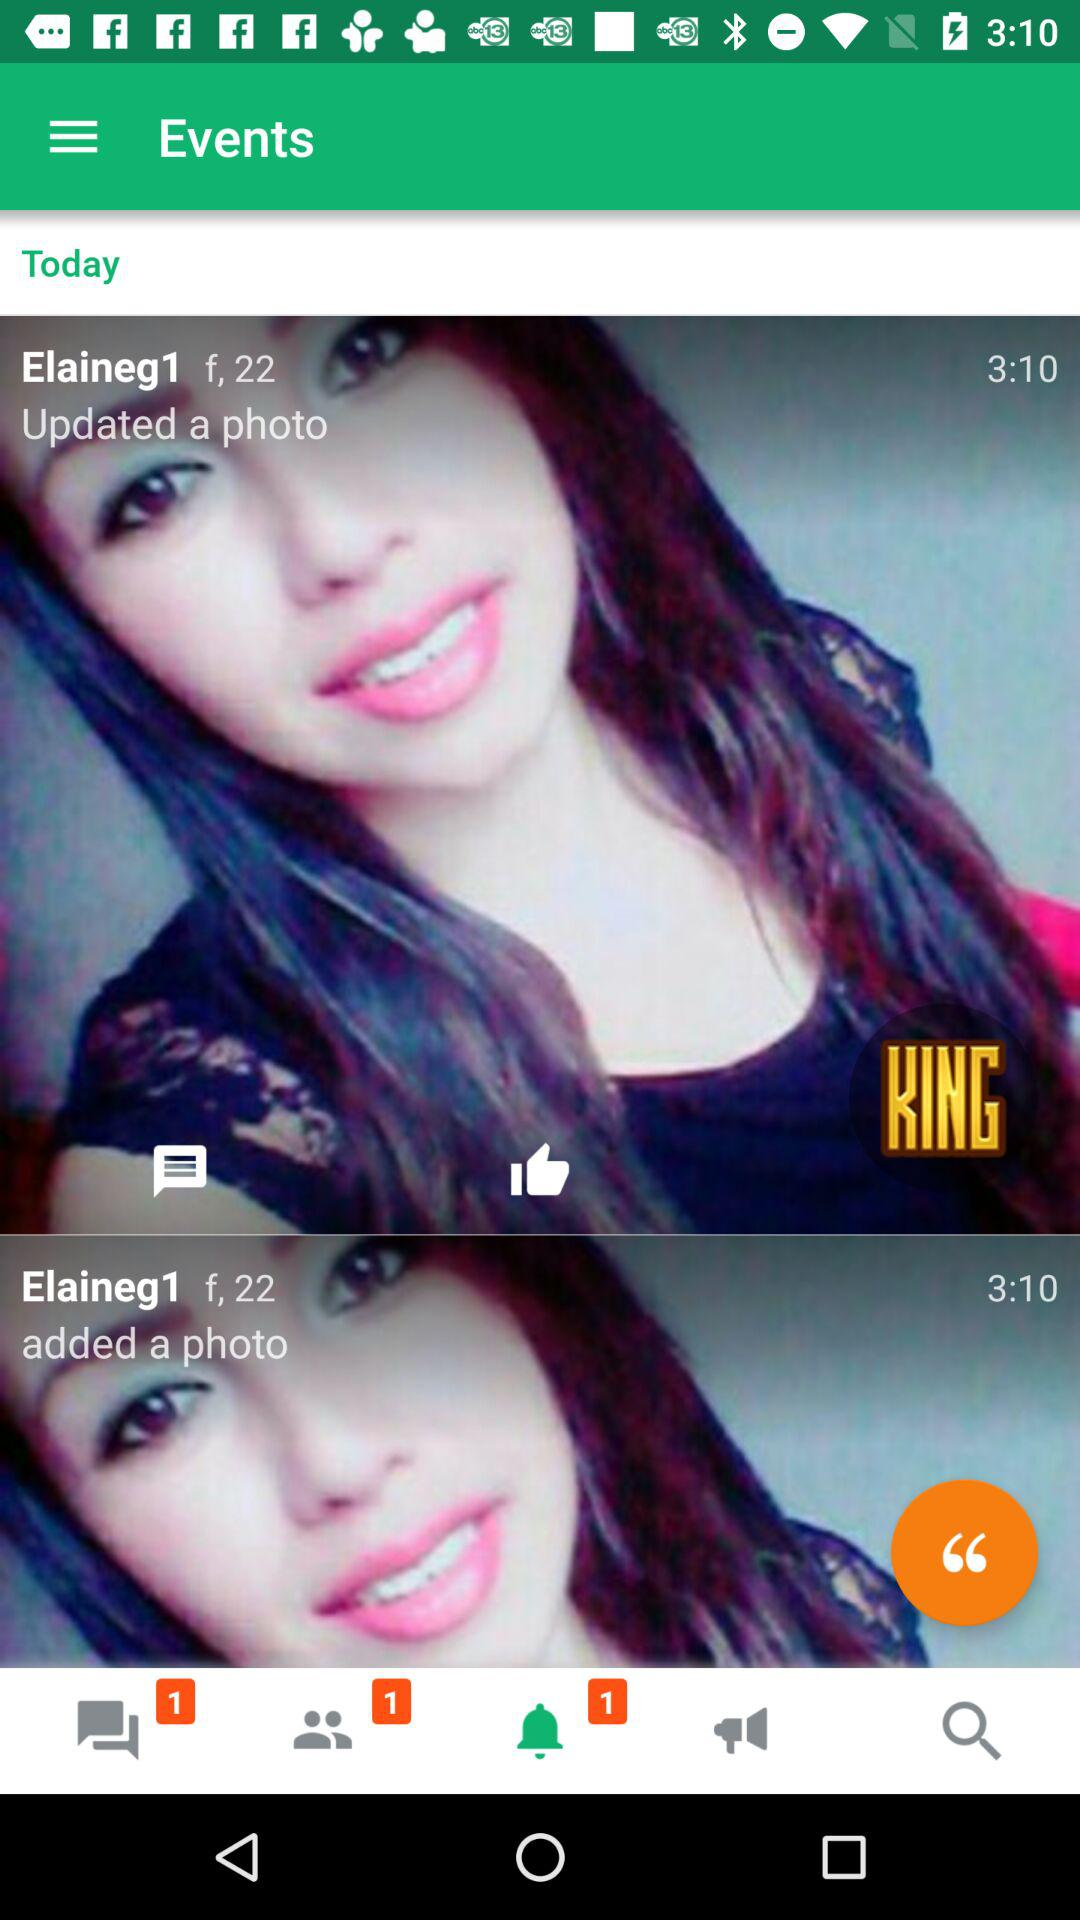How many unread messages are there? There is 1 unread message. 